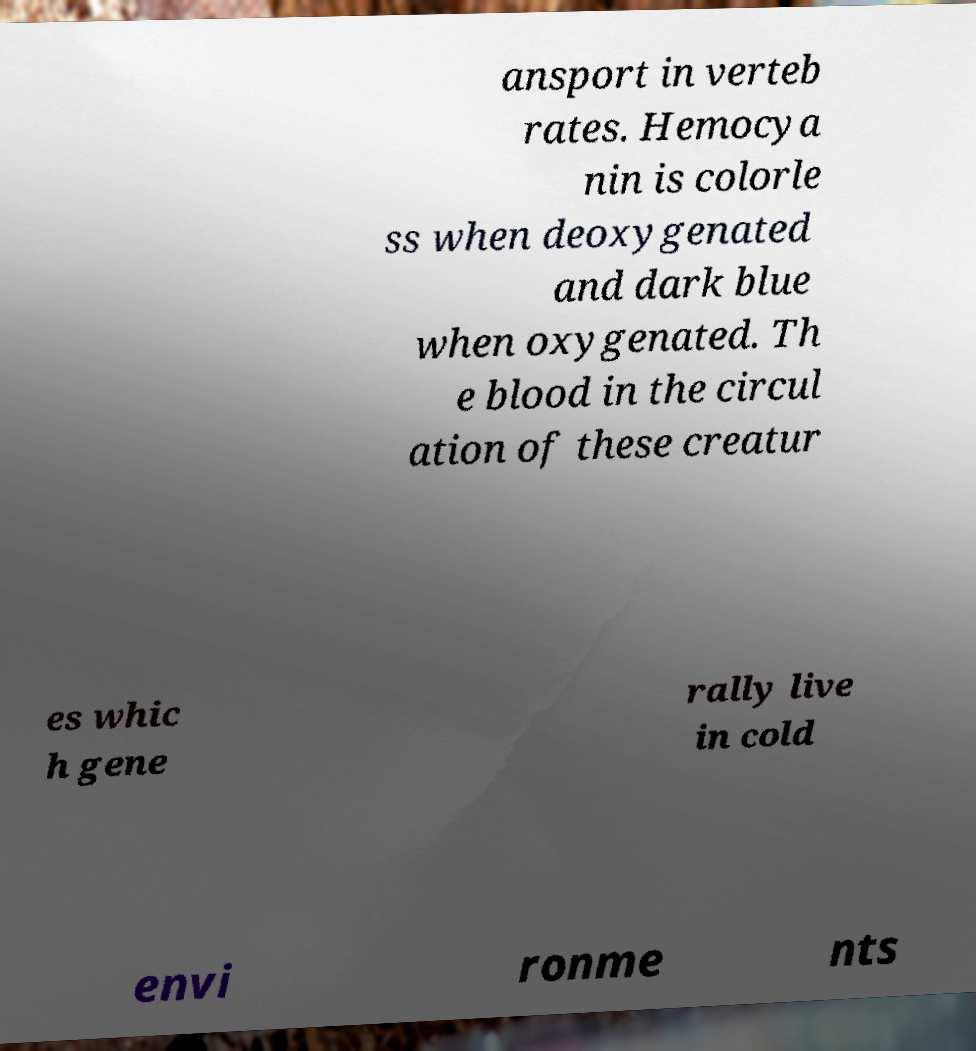There's text embedded in this image that I need extracted. Can you transcribe it verbatim? ansport in verteb rates. Hemocya nin is colorle ss when deoxygenated and dark blue when oxygenated. Th e blood in the circul ation of these creatur es whic h gene rally live in cold envi ronme nts 